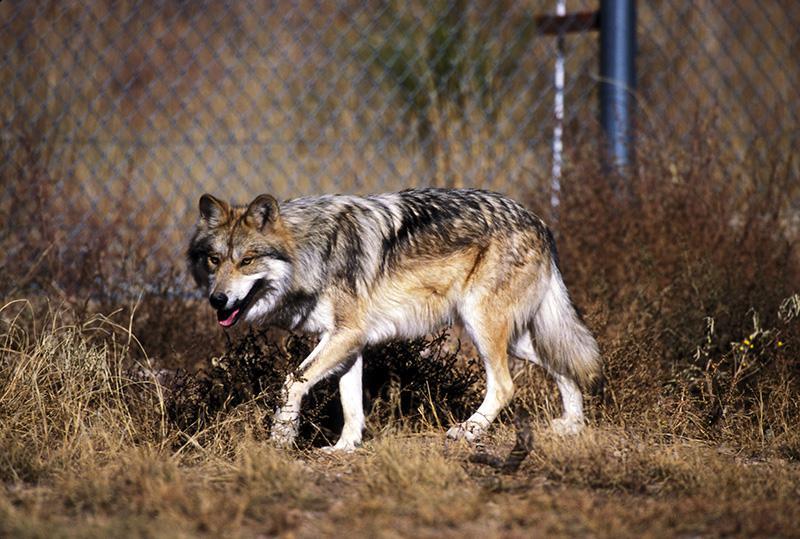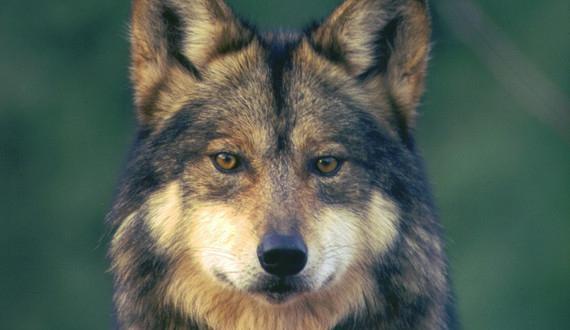The first image is the image on the left, the second image is the image on the right. Considering the images on both sides, is "Each image contains exactly one wolf, and the righthand wolf faces leftward." valid? Answer yes or no. No. The first image is the image on the left, the second image is the image on the right. For the images displayed, is the sentence "The wolf in the right image is facing towards the left." factually correct? Answer yes or no. No. 